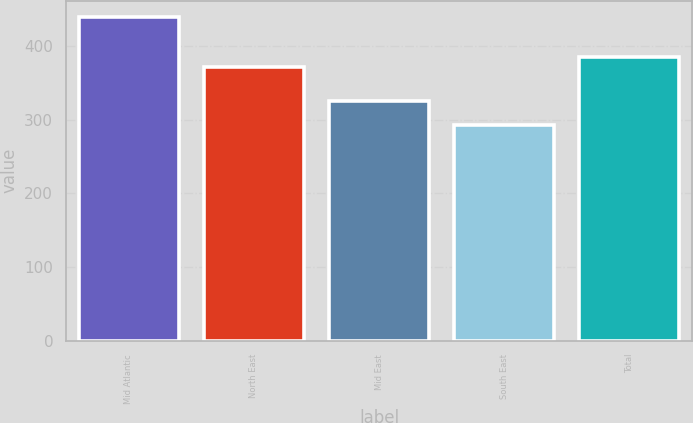Convert chart. <chart><loc_0><loc_0><loc_500><loc_500><bar_chart><fcel>Mid Atlantic<fcel>North East<fcel>Mid East<fcel>South East<fcel>Total<nl><fcel>439.6<fcel>371.1<fcel>325.7<fcel>292.4<fcel>385.82<nl></chart> 